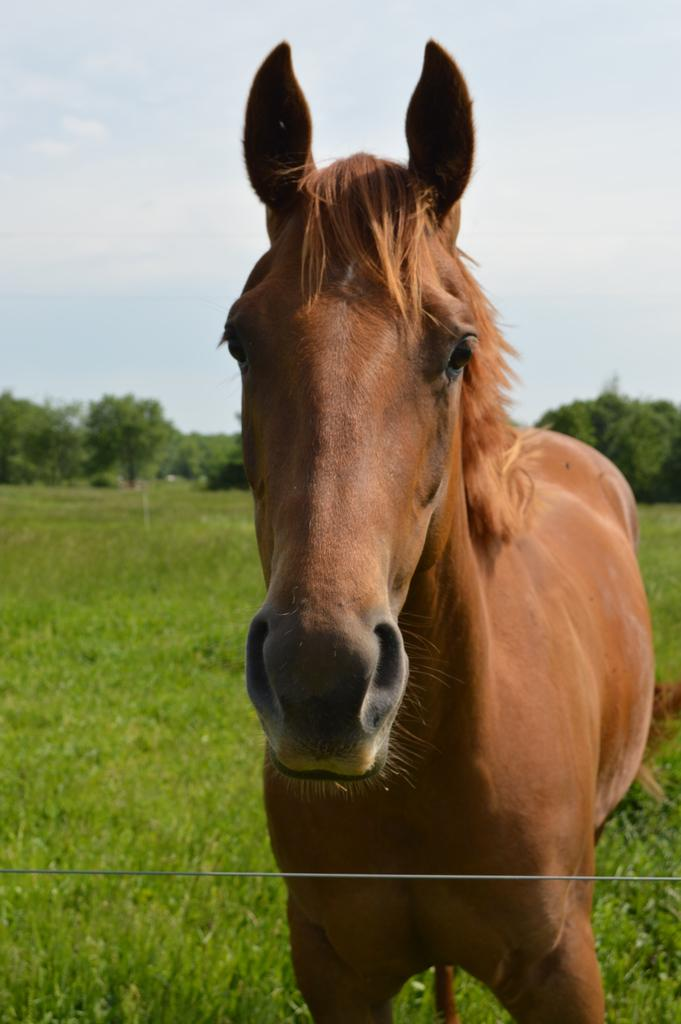What animal is present in the image? There is a horse in the image. What is the horse standing on? The horse is standing on the grass. What can be seen in the background of the image? There are trees visible in the background of the image. What type of grape is the horse eating in the image? There is no grape present in the image, and the horse is not eating anything. Can you describe the horse's position on top of the tree? The horse is not on top of a tree; it is standing on the grass. 